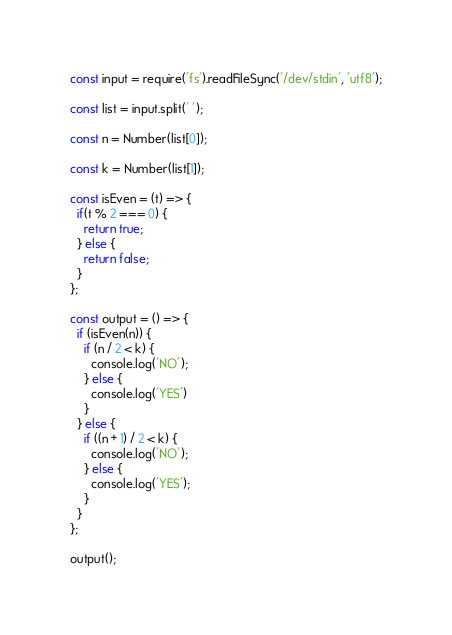Convert code to text. <code><loc_0><loc_0><loc_500><loc_500><_JavaScript_>const input = require('fs').readFileSync('/dev/stdin', 'utf8');

const list = input.split(' ');

const n = Number(list[0]);

const k = Number(list[1]);

const isEven = (t) => {
  if(t % 2 === 0) {
    return true;
  } else {
    return false;
  }
};

const output = () => {
  if (isEven(n)) {
    if (n / 2 < k) {
      console.log('NO');
    } else {
      console.log('YES')
    }
  } else {
    if ((n + 1) / 2 < k) {
      console.log('NO');
    } else {
      console.log('YES');
    }
  }
};

output();
</code> 